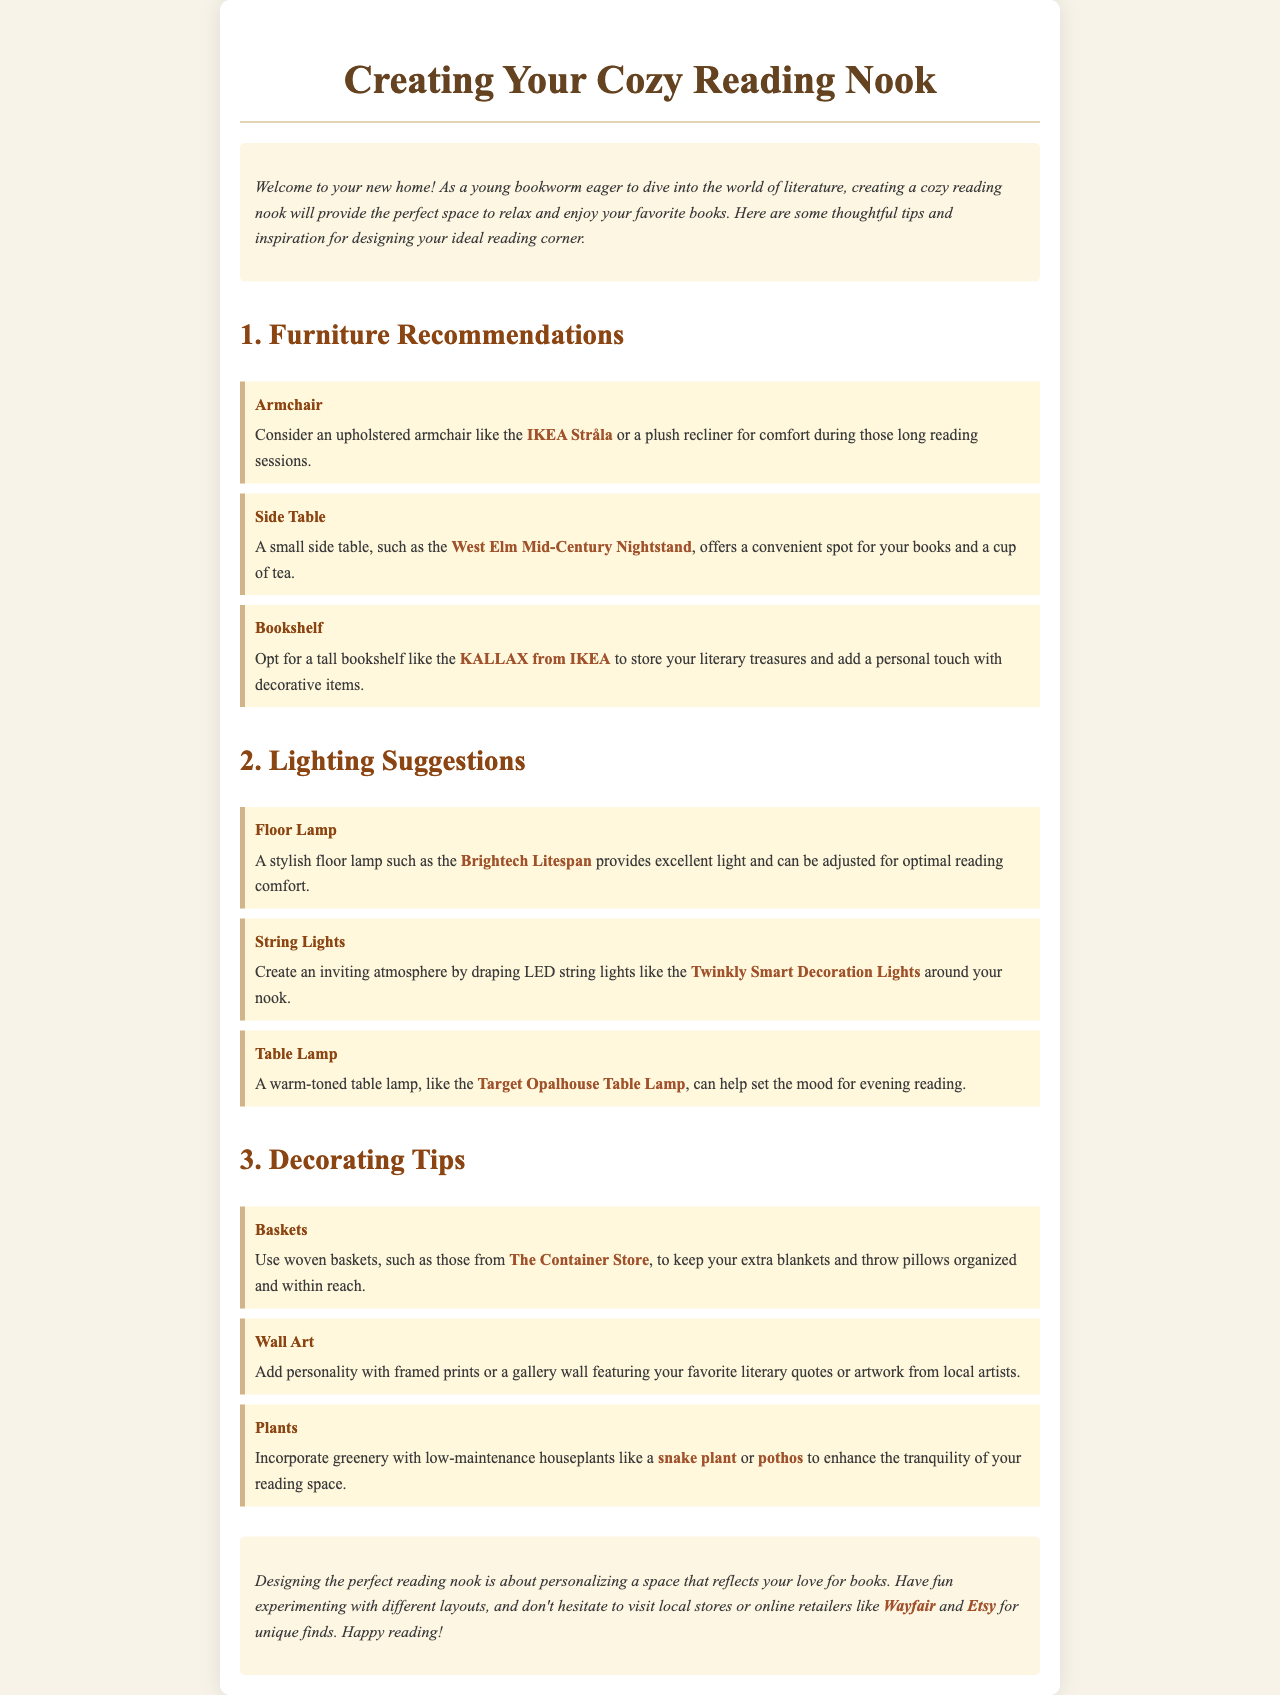what is one furniture recommendation for a cozy reading nook? The document suggests an upholstered armchair like the IKEA Stråla for comfort during reading.
Answer: upholstered armchair what is a suggested side table option? The suggested side table option is the West Elm Mid-Century Nightstand.
Answer: West Elm Mid-Century Nightstand which lamp is recommended for lighting your reading nook? The document recommends the Brightech Litespan for good lighting.
Answer: Brightech Litespan what type of plants are suggested to enhance the reading space? The document suggests low-maintenance houseplants like a snake plant or pothos.
Answer: snake plant or pothos what should you use to keep extra blankets organized? The document recommends using woven baskets to keep extra blankets organized.
Answer: woven baskets how can you create an inviting atmosphere in your nook? The document suggests draping LED string lights around your nook to create an inviting atmosphere.
Answer: LED string lights what is an inspiring additional decor element mentioned? The document mentions adding framed prints or a gallery wall featuring literary quotes as decor elements.
Answer: framed prints or a gallery wall what online retailers are mentioned as good places to find unique items? The retailers mentioned for unique finds are Wayfair and Etsy.
Answer: Wayfair and Etsy what is the overall purpose of designing a reading nook according to the document? The document states that the purpose of designing a reading nook is to personalize a space that reflects your love for books.
Answer: personalize a space that reflects your love for books 